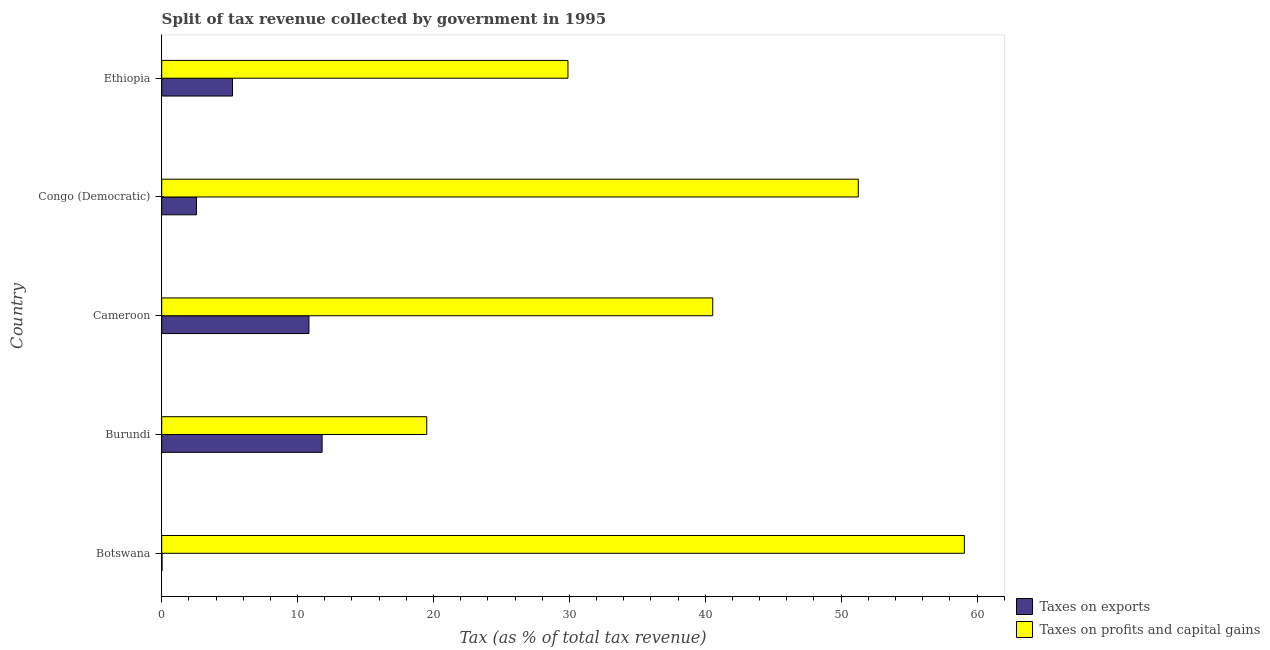How many groups of bars are there?
Your answer should be compact. 5. Are the number of bars per tick equal to the number of legend labels?
Offer a very short reply. Yes. Are the number of bars on each tick of the Y-axis equal?
Ensure brevity in your answer.  Yes. How many bars are there on the 1st tick from the bottom?
Provide a succinct answer. 2. What is the label of the 1st group of bars from the top?
Keep it short and to the point. Ethiopia. In how many cases, is the number of bars for a given country not equal to the number of legend labels?
Make the answer very short. 0. What is the percentage of revenue obtained from taxes on exports in Botswana?
Ensure brevity in your answer.  0.02. Across all countries, what is the maximum percentage of revenue obtained from taxes on profits and capital gains?
Give a very brief answer. 59.07. Across all countries, what is the minimum percentage of revenue obtained from taxes on exports?
Ensure brevity in your answer.  0.02. In which country was the percentage of revenue obtained from taxes on exports maximum?
Provide a succinct answer. Burundi. In which country was the percentage of revenue obtained from taxes on profits and capital gains minimum?
Provide a succinct answer. Burundi. What is the total percentage of revenue obtained from taxes on profits and capital gains in the graph?
Your answer should be compact. 200.28. What is the difference between the percentage of revenue obtained from taxes on exports in Botswana and that in Cameroon?
Your answer should be compact. -10.81. What is the difference between the percentage of revenue obtained from taxes on exports in Botswana and the percentage of revenue obtained from taxes on profits and capital gains in Burundi?
Offer a terse response. -19.48. What is the average percentage of revenue obtained from taxes on profits and capital gains per country?
Offer a terse response. 40.06. What is the difference between the percentage of revenue obtained from taxes on exports and percentage of revenue obtained from taxes on profits and capital gains in Cameroon?
Give a very brief answer. -29.72. In how many countries, is the percentage of revenue obtained from taxes on exports greater than 14 %?
Your response must be concise. 0. What is the ratio of the percentage of revenue obtained from taxes on profits and capital gains in Congo (Democratic) to that in Ethiopia?
Your answer should be compact. 1.72. What is the difference between the highest and the lowest percentage of revenue obtained from taxes on exports?
Provide a short and direct response. 11.78. Is the sum of the percentage of revenue obtained from taxes on exports in Botswana and Burundi greater than the maximum percentage of revenue obtained from taxes on profits and capital gains across all countries?
Your answer should be very brief. No. What does the 2nd bar from the top in Congo (Democratic) represents?
Offer a very short reply. Taxes on exports. What does the 1st bar from the bottom in Ethiopia represents?
Ensure brevity in your answer.  Taxes on exports. How many bars are there?
Offer a terse response. 10. Are all the bars in the graph horizontal?
Offer a very short reply. Yes. How many legend labels are there?
Make the answer very short. 2. How are the legend labels stacked?
Make the answer very short. Vertical. What is the title of the graph?
Ensure brevity in your answer.  Split of tax revenue collected by government in 1995. Does "current US$" appear as one of the legend labels in the graph?
Your answer should be very brief. No. What is the label or title of the X-axis?
Offer a terse response. Tax (as % of total tax revenue). What is the label or title of the Y-axis?
Offer a terse response. Country. What is the Tax (as % of total tax revenue) of Taxes on exports in Botswana?
Your response must be concise. 0.02. What is the Tax (as % of total tax revenue) in Taxes on profits and capital gains in Botswana?
Provide a short and direct response. 59.07. What is the Tax (as % of total tax revenue) of Taxes on exports in Burundi?
Ensure brevity in your answer.  11.8. What is the Tax (as % of total tax revenue) of Taxes on profits and capital gains in Burundi?
Your answer should be very brief. 19.5. What is the Tax (as % of total tax revenue) in Taxes on exports in Cameroon?
Your answer should be compact. 10.83. What is the Tax (as % of total tax revenue) of Taxes on profits and capital gains in Cameroon?
Your answer should be compact. 40.55. What is the Tax (as % of total tax revenue) in Taxes on exports in Congo (Democratic)?
Your response must be concise. 2.56. What is the Tax (as % of total tax revenue) of Taxes on profits and capital gains in Congo (Democratic)?
Keep it short and to the point. 51.26. What is the Tax (as % of total tax revenue) of Taxes on exports in Ethiopia?
Keep it short and to the point. 5.21. What is the Tax (as % of total tax revenue) of Taxes on profits and capital gains in Ethiopia?
Provide a short and direct response. 29.9. Across all countries, what is the maximum Tax (as % of total tax revenue) of Taxes on exports?
Provide a short and direct response. 11.8. Across all countries, what is the maximum Tax (as % of total tax revenue) of Taxes on profits and capital gains?
Give a very brief answer. 59.07. Across all countries, what is the minimum Tax (as % of total tax revenue) in Taxes on exports?
Offer a terse response. 0.02. Across all countries, what is the minimum Tax (as % of total tax revenue) of Taxes on profits and capital gains?
Ensure brevity in your answer.  19.5. What is the total Tax (as % of total tax revenue) in Taxes on exports in the graph?
Your response must be concise. 30.43. What is the total Tax (as % of total tax revenue) of Taxes on profits and capital gains in the graph?
Offer a very short reply. 200.28. What is the difference between the Tax (as % of total tax revenue) of Taxes on exports in Botswana and that in Burundi?
Make the answer very short. -11.78. What is the difference between the Tax (as % of total tax revenue) of Taxes on profits and capital gains in Botswana and that in Burundi?
Give a very brief answer. 39.56. What is the difference between the Tax (as % of total tax revenue) in Taxes on exports in Botswana and that in Cameroon?
Offer a very short reply. -10.81. What is the difference between the Tax (as % of total tax revenue) in Taxes on profits and capital gains in Botswana and that in Cameroon?
Your answer should be very brief. 18.52. What is the difference between the Tax (as % of total tax revenue) in Taxes on exports in Botswana and that in Congo (Democratic)?
Offer a terse response. -2.53. What is the difference between the Tax (as % of total tax revenue) of Taxes on profits and capital gains in Botswana and that in Congo (Democratic)?
Provide a succinct answer. 7.81. What is the difference between the Tax (as % of total tax revenue) of Taxes on exports in Botswana and that in Ethiopia?
Offer a terse response. -5.19. What is the difference between the Tax (as % of total tax revenue) in Taxes on profits and capital gains in Botswana and that in Ethiopia?
Make the answer very short. 29.17. What is the difference between the Tax (as % of total tax revenue) in Taxes on exports in Burundi and that in Cameroon?
Provide a short and direct response. 0.97. What is the difference between the Tax (as % of total tax revenue) in Taxes on profits and capital gains in Burundi and that in Cameroon?
Offer a terse response. -21.05. What is the difference between the Tax (as % of total tax revenue) of Taxes on exports in Burundi and that in Congo (Democratic)?
Ensure brevity in your answer.  9.25. What is the difference between the Tax (as % of total tax revenue) in Taxes on profits and capital gains in Burundi and that in Congo (Democratic)?
Keep it short and to the point. -31.76. What is the difference between the Tax (as % of total tax revenue) in Taxes on exports in Burundi and that in Ethiopia?
Make the answer very short. 6.59. What is the difference between the Tax (as % of total tax revenue) in Taxes on profits and capital gains in Burundi and that in Ethiopia?
Provide a short and direct response. -10.39. What is the difference between the Tax (as % of total tax revenue) of Taxes on exports in Cameroon and that in Congo (Democratic)?
Provide a succinct answer. 8.28. What is the difference between the Tax (as % of total tax revenue) in Taxes on profits and capital gains in Cameroon and that in Congo (Democratic)?
Keep it short and to the point. -10.71. What is the difference between the Tax (as % of total tax revenue) in Taxes on exports in Cameroon and that in Ethiopia?
Make the answer very short. 5.62. What is the difference between the Tax (as % of total tax revenue) in Taxes on profits and capital gains in Cameroon and that in Ethiopia?
Your answer should be very brief. 10.65. What is the difference between the Tax (as % of total tax revenue) of Taxes on exports in Congo (Democratic) and that in Ethiopia?
Your answer should be very brief. -2.65. What is the difference between the Tax (as % of total tax revenue) of Taxes on profits and capital gains in Congo (Democratic) and that in Ethiopia?
Provide a short and direct response. 21.37. What is the difference between the Tax (as % of total tax revenue) in Taxes on exports in Botswana and the Tax (as % of total tax revenue) in Taxes on profits and capital gains in Burundi?
Keep it short and to the point. -19.48. What is the difference between the Tax (as % of total tax revenue) of Taxes on exports in Botswana and the Tax (as % of total tax revenue) of Taxes on profits and capital gains in Cameroon?
Ensure brevity in your answer.  -40.53. What is the difference between the Tax (as % of total tax revenue) in Taxes on exports in Botswana and the Tax (as % of total tax revenue) in Taxes on profits and capital gains in Congo (Democratic)?
Keep it short and to the point. -51.24. What is the difference between the Tax (as % of total tax revenue) in Taxes on exports in Botswana and the Tax (as % of total tax revenue) in Taxes on profits and capital gains in Ethiopia?
Ensure brevity in your answer.  -29.87. What is the difference between the Tax (as % of total tax revenue) of Taxes on exports in Burundi and the Tax (as % of total tax revenue) of Taxes on profits and capital gains in Cameroon?
Give a very brief answer. -28.75. What is the difference between the Tax (as % of total tax revenue) in Taxes on exports in Burundi and the Tax (as % of total tax revenue) in Taxes on profits and capital gains in Congo (Democratic)?
Make the answer very short. -39.46. What is the difference between the Tax (as % of total tax revenue) of Taxes on exports in Burundi and the Tax (as % of total tax revenue) of Taxes on profits and capital gains in Ethiopia?
Provide a short and direct response. -18.09. What is the difference between the Tax (as % of total tax revenue) of Taxes on exports in Cameroon and the Tax (as % of total tax revenue) of Taxes on profits and capital gains in Congo (Democratic)?
Ensure brevity in your answer.  -40.43. What is the difference between the Tax (as % of total tax revenue) in Taxes on exports in Cameroon and the Tax (as % of total tax revenue) in Taxes on profits and capital gains in Ethiopia?
Make the answer very short. -19.06. What is the difference between the Tax (as % of total tax revenue) of Taxes on exports in Congo (Democratic) and the Tax (as % of total tax revenue) of Taxes on profits and capital gains in Ethiopia?
Your response must be concise. -27.34. What is the average Tax (as % of total tax revenue) in Taxes on exports per country?
Ensure brevity in your answer.  6.09. What is the average Tax (as % of total tax revenue) of Taxes on profits and capital gains per country?
Your answer should be compact. 40.06. What is the difference between the Tax (as % of total tax revenue) of Taxes on exports and Tax (as % of total tax revenue) of Taxes on profits and capital gains in Botswana?
Your answer should be compact. -59.05. What is the difference between the Tax (as % of total tax revenue) in Taxes on exports and Tax (as % of total tax revenue) in Taxes on profits and capital gains in Burundi?
Ensure brevity in your answer.  -7.7. What is the difference between the Tax (as % of total tax revenue) of Taxes on exports and Tax (as % of total tax revenue) of Taxes on profits and capital gains in Cameroon?
Provide a short and direct response. -29.72. What is the difference between the Tax (as % of total tax revenue) of Taxes on exports and Tax (as % of total tax revenue) of Taxes on profits and capital gains in Congo (Democratic)?
Make the answer very short. -48.7. What is the difference between the Tax (as % of total tax revenue) in Taxes on exports and Tax (as % of total tax revenue) in Taxes on profits and capital gains in Ethiopia?
Your answer should be very brief. -24.69. What is the ratio of the Tax (as % of total tax revenue) of Taxes on exports in Botswana to that in Burundi?
Provide a succinct answer. 0. What is the ratio of the Tax (as % of total tax revenue) in Taxes on profits and capital gains in Botswana to that in Burundi?
Ensure brevity in your answer.  3.03. What is the ratio of the Tax (as % of total tax revenue) of Taxes on exports in Botswana to that in Cameroon?
Offer a very short reply. 0. What is the ratio of the Tax (as % of total tax revenue) of Taxes on profits and capital gains in Botswana to that in Cameroon?
Offer a very short reply. 1.46. What is the ratio of the Tax (as % of total tax revenue) in Taxes on exports in Botswana to that in Congo (Democratic)?
Offer a terse response. 0.01. What is the ratio of the Tax (as % of total tax revenue) of Taxes on profits and capital gains in Botswana to that in Congo (Democratic)?
Your answer should be compact. 1.15. What is the ratio of the Tax (as % of total tax revenue) of Taxes on exports in Botswana to that in Ethiopia?
Ensure brevity in your answer.  0. What is the ratio of the Tax (as % of total tax revenue) of Taxes on profits and capital gains in Botswana to that in Ethiopia?
Your response must be concise. 1.98. What is the ratio of the Tax (as % of total tax revenue) of Taxes on exports in Burundi to that in Cameroon?
Offer a terse response. 1.09. What is the ratio of the Tax (as % of total tax revenue) of Taxes on profits and capital gains in Burundi to that in Cameroon?
Give a very brief answer. 0.48. What is the ratio of the Tax (as % of total tax revenue) of Taxes on exports in Burundi to that in Congo (Democratic)?
Provide a succinct answer. 4.62. What is the ratio of the Tax (as % of total tax revenue) in Taxes on profits and capital gains in Burundi to that in Congo (Democratic)?
Keep it short and to the point. 0.38. What is the ratio of the Tax (as % of total tax revenue) in Taxes on exports in Burundi to that in Ethiopia?
Ensure brevity in your answer.  2.27. What is the ratio of the Tax (as % of total tax revenue) of Taxes on profits and capital gains in Burundi to that in Ethiopia?
Your response must be concise. 0.65. What is the ratio of the Tax (as % of total tax revenue) in Taxes on exports in Cameroon to that in Congo (Democratic)?
Ensure brevity in your answer.  4.24. What is the ratio of the Tax (as % of total tax revenue) of Taxes on profits and capital gains in Cameroon to that in Congo (Democratic)?
Offer a terse response. 0.79. What is the ratio of the Tax (as % of total tax revenue) of Taxes on exports in Cameroon to that in Ethiopia?
Offer a terse response. 2.08. What is the ratio of the Tax (as % of total tax revenue) in Taxes on profits and capital gains in Cameroon to that in Ethiopia?
Offer a very short reply. 1.36. What is the ratio of the Tax (as % of total tax revenue) in Taxes on exports in Congo (Democratic) to that in Ethiopia?
Your answer should be compact. 0.49. What is the ratio of the Tax (as % of total tax revenue) in Taxes on profits and capital gains in Congo (Democratic) to that in Ethiopia?
Ensure brevity in your answer.  1.71. What is the difference between the highest and the second highest Tax (as % of total tax revenue) of Taxes on exports?
Your response must be concise. 0.97. What is the difference between the highest and the second highest Tax (as % of total tax revenue) in Taxes on profits and capital gains?
Your response must be concise. 7.81. What is the difference between the highest and the lowest Tax (as % of total tax revenue) in Taxes on exports?
Ensure brevity in your answer.  11.78. What is the difference between the highest and the lowest Tax (as % of total tax revenue) of Taxes on profits and capital gains?
Ensure brevity in your answer.  39.56. 